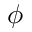Convert formula to latex. <formula><loc_0><loc_0><loc_500><loc_500>\phi</formula> 